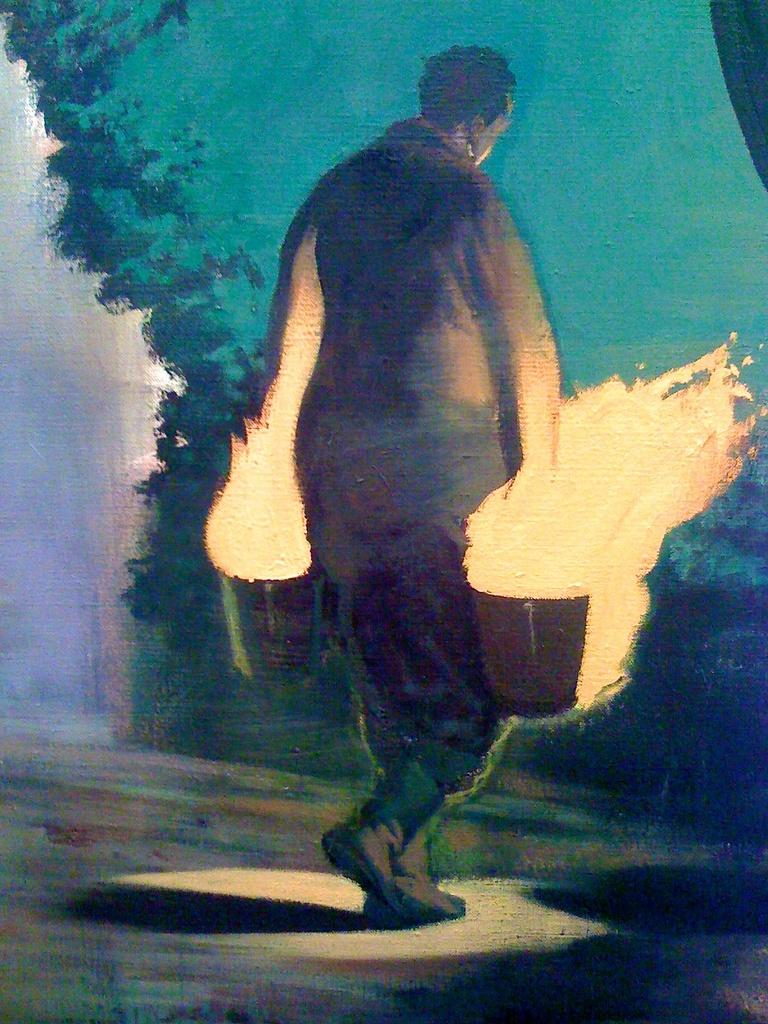What is the main subject of the image? There is a painting in the image. What is the painting depicting? The painting depicts a person walking. What type of insect can be seen flying around the person in the painting? There is no insect present in the painting; it depicts a person walking. How many pears are visible in the painting? There are no pears present in the painting; it depicts a person walking. 